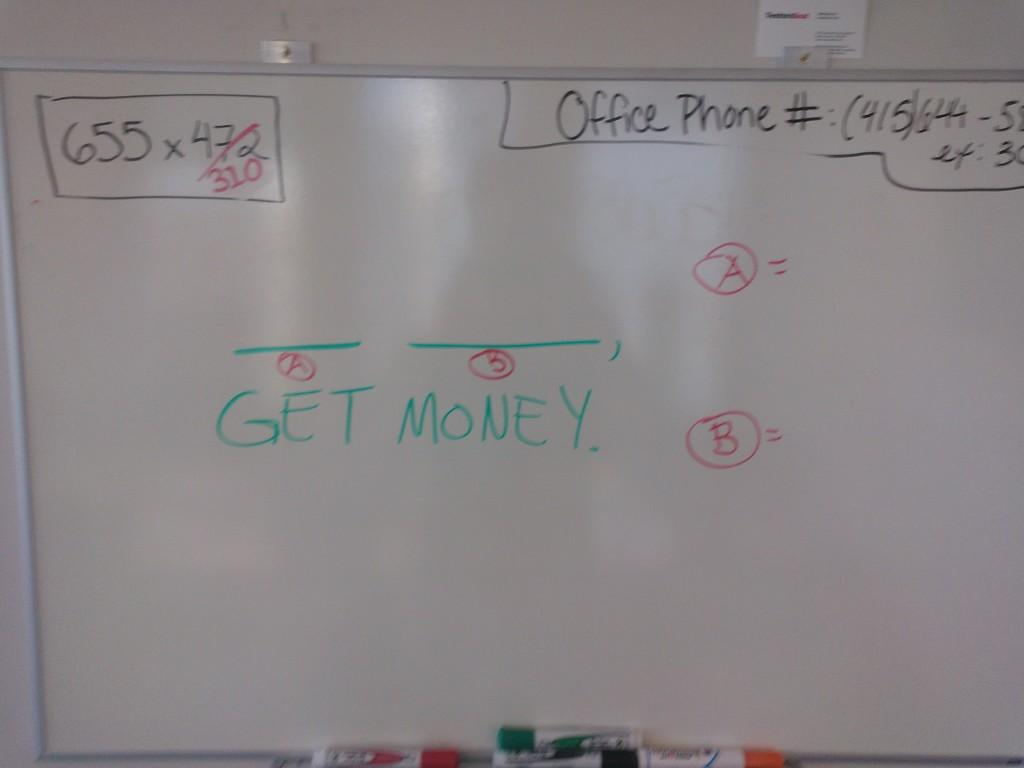<image>
Describe the image concisely. A white board with the words Get Money written on it 